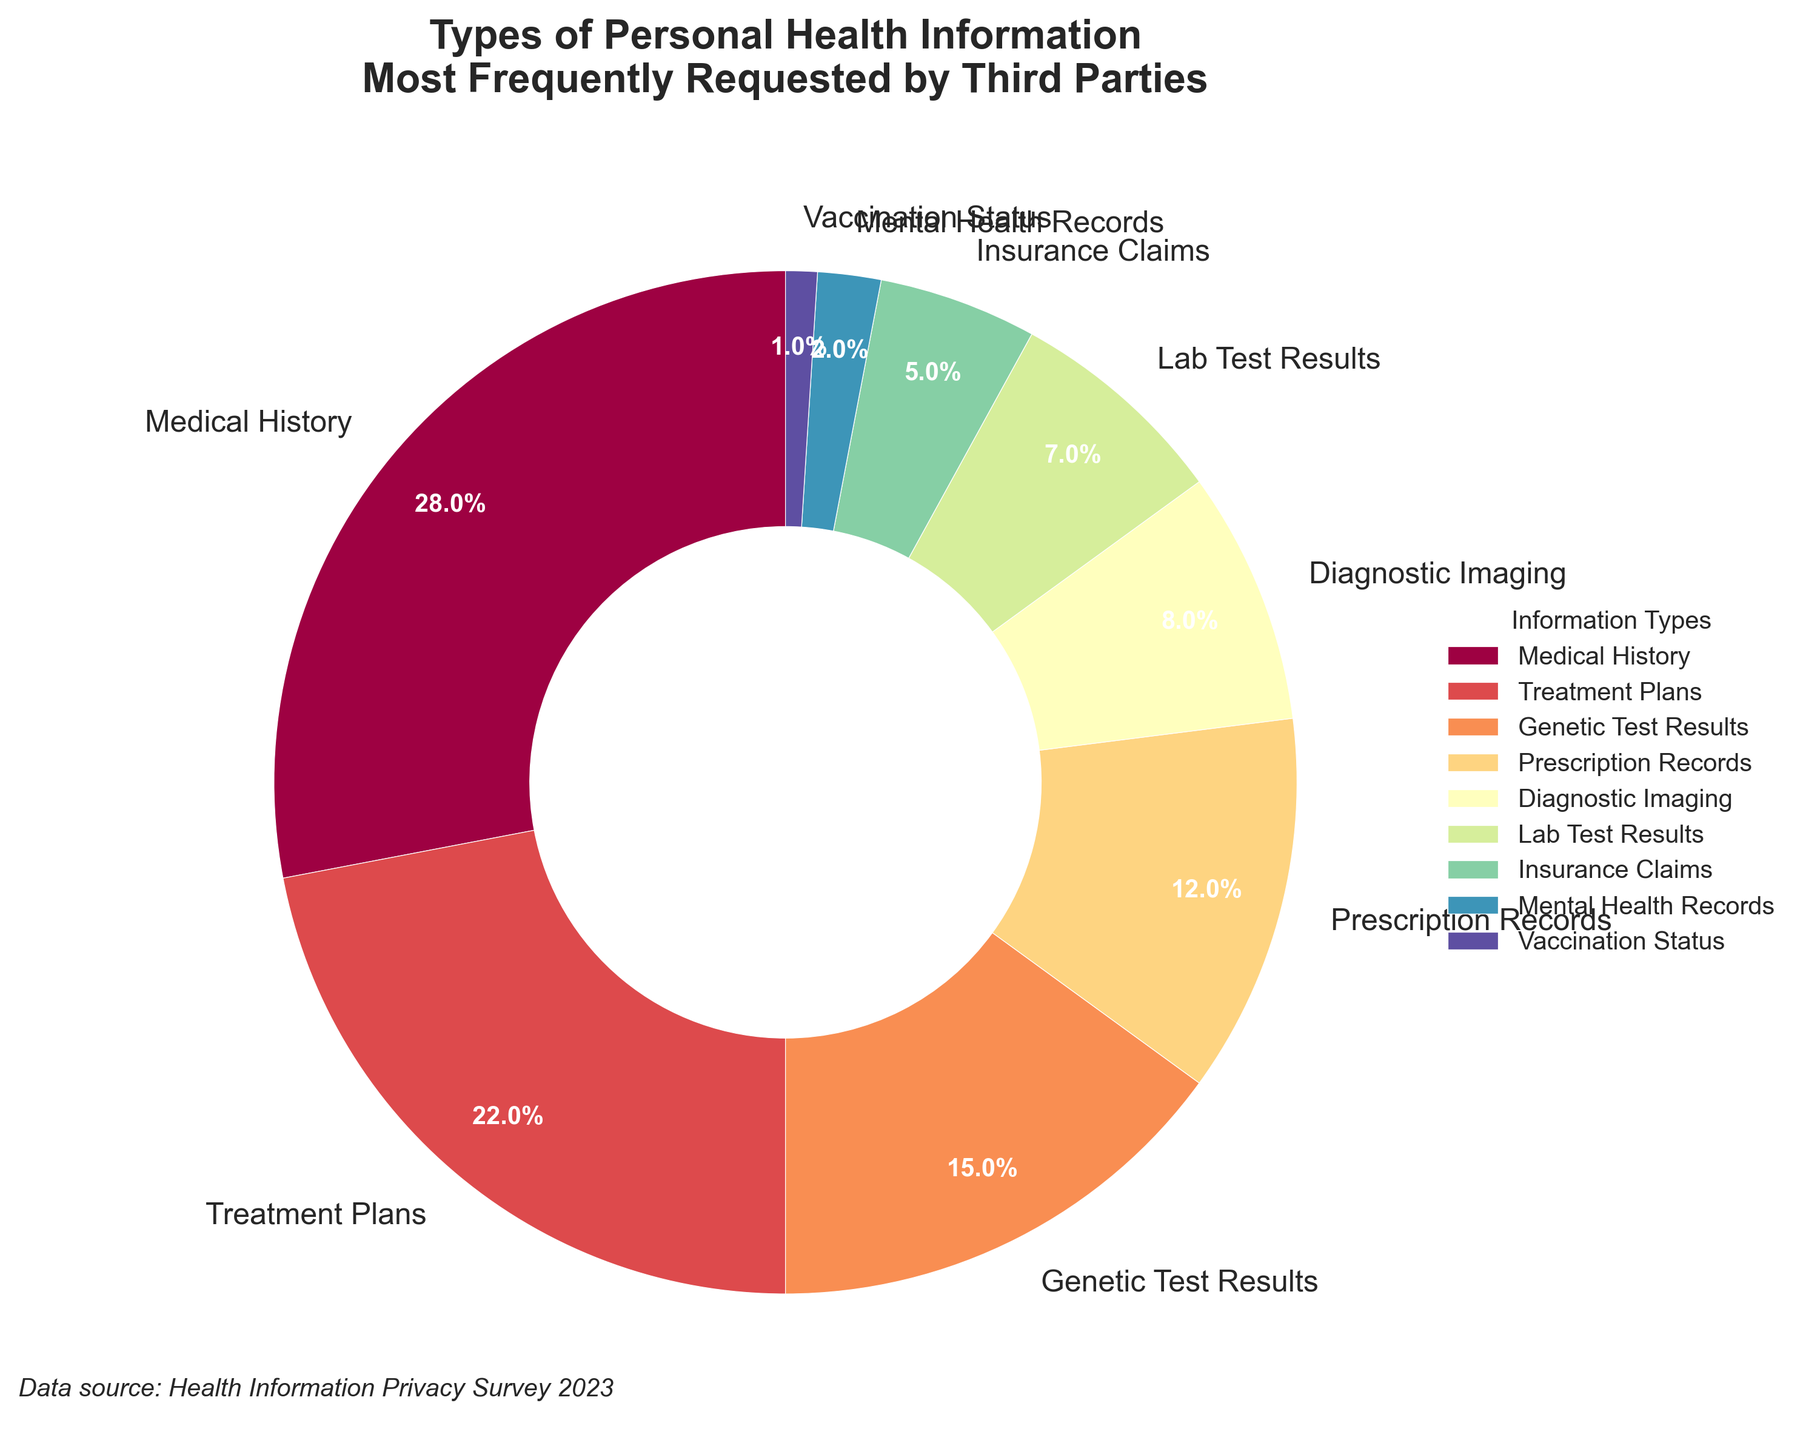What type of personal health information is most frequently requested by third parties? The type of personal health information most frequently requested is represented by the largest wedge in the pie chart. According to the visual information, "Medical History" has the largest portion.
Answer: Medical History How much more frequently is "Medical History" requested compared to "Vaccination Status"? To determine this, we subtract the percentage of "Vaccination Status" from "Medical History". "Medical History" is 28% and "Vaccination Status" is 1%, so 28% - 1% = 27%.
Answer: 27% Which two types of information combined make up less than 10% of the requests? By inspecting the smaller slices of the pie chart, we see "Mental Health Records" at 2% and "Vaccination Status" at 1%. Adding them together, we get 2% + 1% = 3%, which is less than 10%.
Answer: Mental Health Records and Vaccination Status Compare the frequency of requests for "Genetic Test Results" and "Prescription Records". Looking at the pie chart, "Genetic Test Results" represent 15% while "Prescription Records" represent 12%. Therefore, "Genetic Test Results" are requested more frequently than "Prescription Records".
Answer: Genetic Test Results What percentage of the requests are made up by "Lab Test Results" and "Insurance Claims" together? We add the percentage of "Lab Test Results" (7%) and "Insurance Claims" (5%). 7% + 5% = 12%.
Answer: 12% Which type of information has nearly a quarter of the requests, and how close is it to that fraction? "Medical History" has 28% of requests. One quarter translates to 25%. The difference is 28% - 25% = 3%, so it is 3% more than a quarter.
Answer: Medical History, 3% more Describe the color of the wedge representing "Treatment Plans". By referring to the color distribution of the pie chart, and locating the "Treatment Plans" wedge after "Medical History", it appears in a shade derived from the colormap, possibly towards the middle shades used.
Answer: Shade towards the middle in the colormap What is the cumulative percentage of the three least requested types of information? The three least requested types are "Vaccination Status" (1%), "Mental Health Records" (2%), and "Insurance Claims" (5%). Adding them together: 1% + 2% + 5% = 8%.
Answer: 8% How many types of personal health information are requested at least 10% of the time? From the pie chart, "Medical History" (28%), "Treatment Plans" (22%), "Genetic Test Results" (15%), and "Prescription Records" (12%) are all 10% or more. This gives us a count of four types.
Answer: Four types 